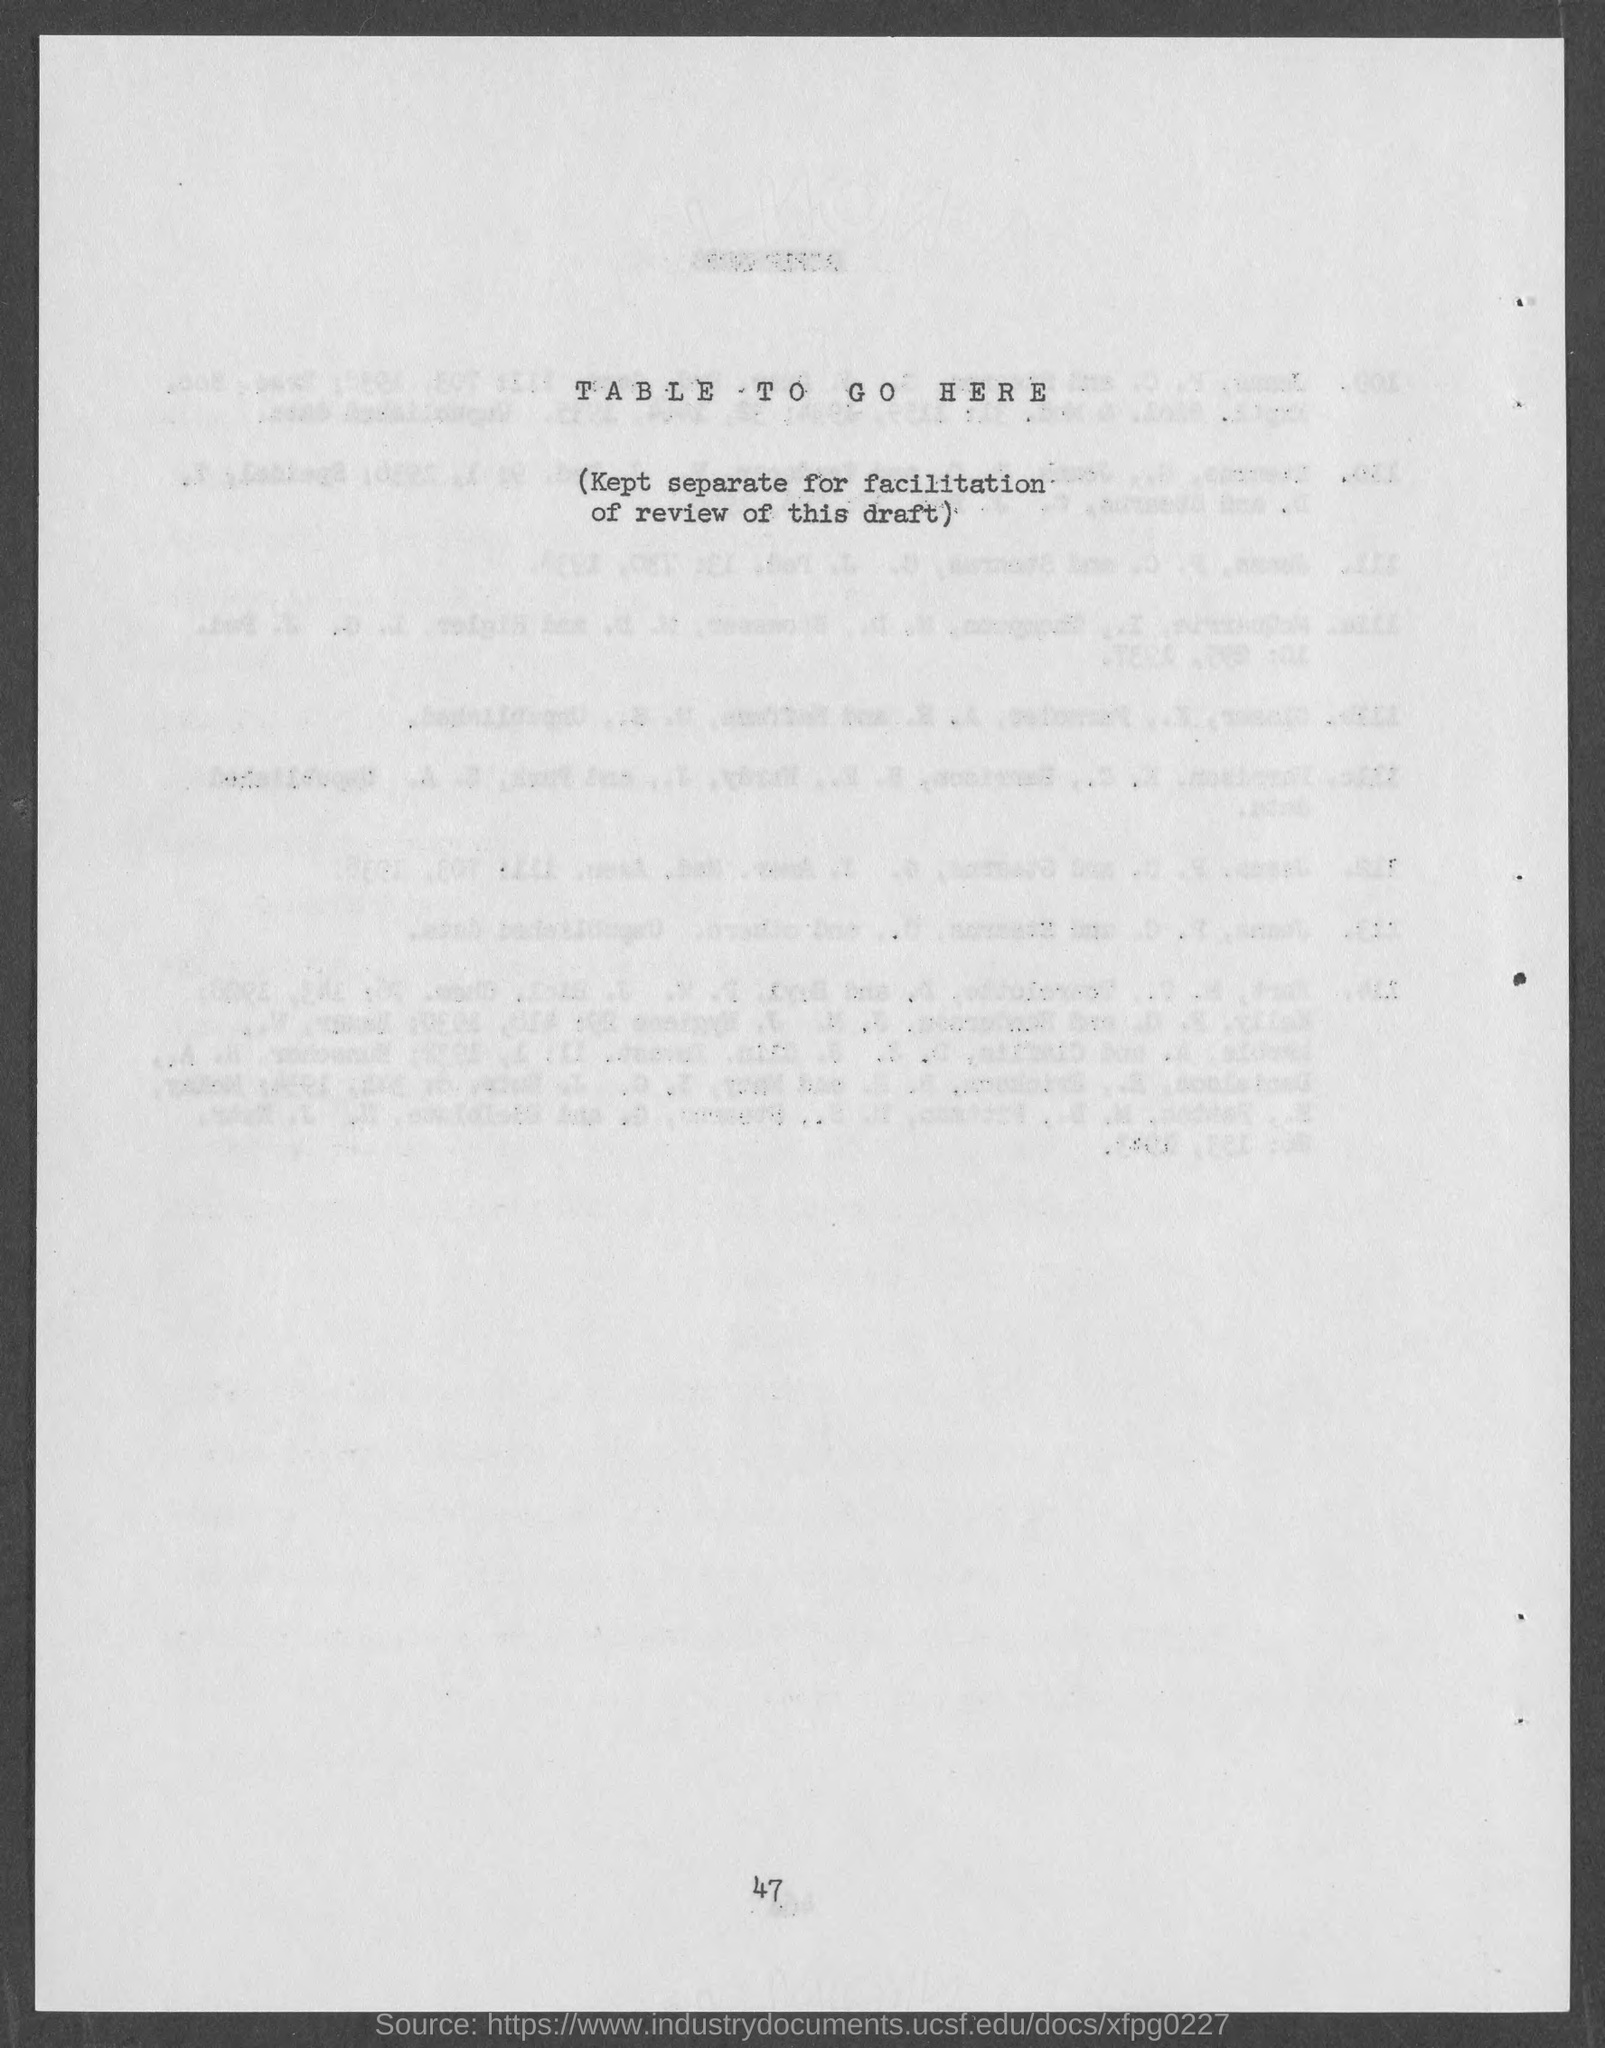Outline some significant characteristics in this image. The page number at the bottom of the page is 47. 